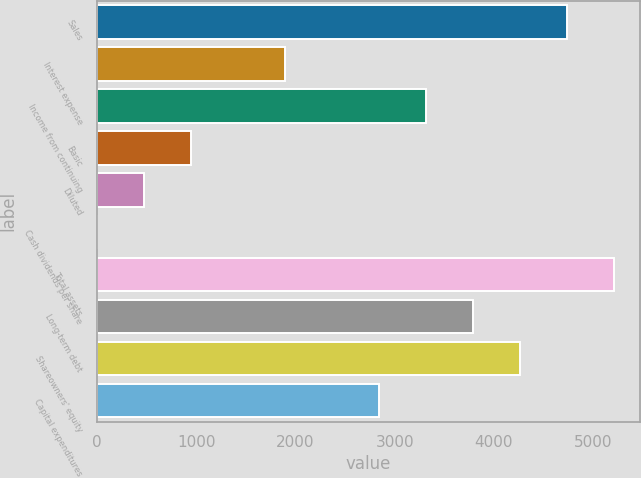Convert chart. <chart><loc_0><loc_0><loc_500><loc_500><bar_chart><fcel>Sales<fcel>Interest expense<fcel>Income from continuing<fcel>Basic<fcel>Diluted<fcel>Cash dividends per share<fcel>Total assets<fcel>Long-term debt<fcel>Shareowners' equity<fcel>Capital expenditures<nl><fcel>4735.4<fcel>1894.7<fcel>3315.05<fcel>947.8<fcel>474.35<fcel>0.9<fcel>5208.85<fcel>3788.5<fcel>4261.95<fcel>2841.6<nl></chart> 